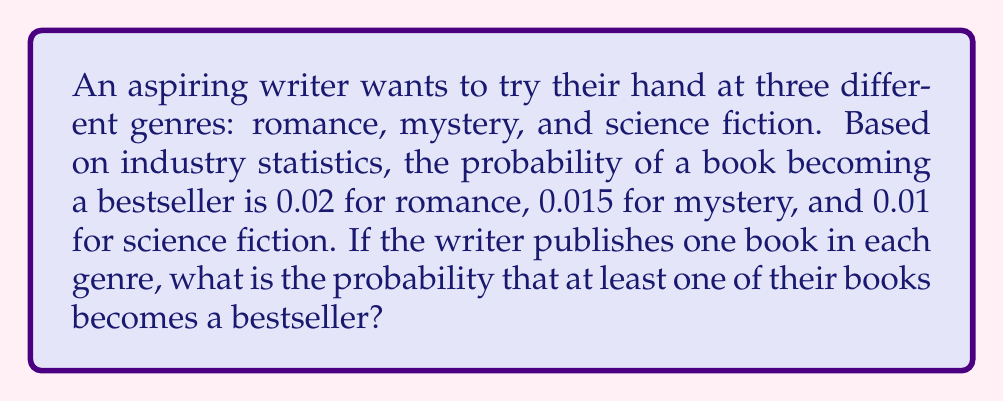Solve this math problem. Let's approach this step-by-step:

1) First, we need to calculate the probability that none of the books become bestsellers. We can then subtract this from 1 to get the probability that at least one book becomes a bestseller.

2) The probability of a book not becoming a bestseller is:
   - For romance: $1 - 0.02 = 0.98$
   - For mystery: $1 - 0.015 = 0.985$
   - For science fiction: $1 - 0.01 = 0.99$

3) The probability that all three books fail to become bestsellers is the product of these probabilities:

   $$P(\text{no bestsellers}) = 0.98 \times 0.985 \times 0.99 = 0.955683$$

4) Therefore, the probability that at least one book becomes a bestseller is:

   $$P(\text{at least one bestseller}) = 1 - P(\text{no bestsellers})$$
   $$= 1 - 0.955683 = 0.044317$$

5) We can express this as a percentage:

   $$0.044317 \times 100\% = 4.4317\%$$
Answer: $4.4317\%$ 